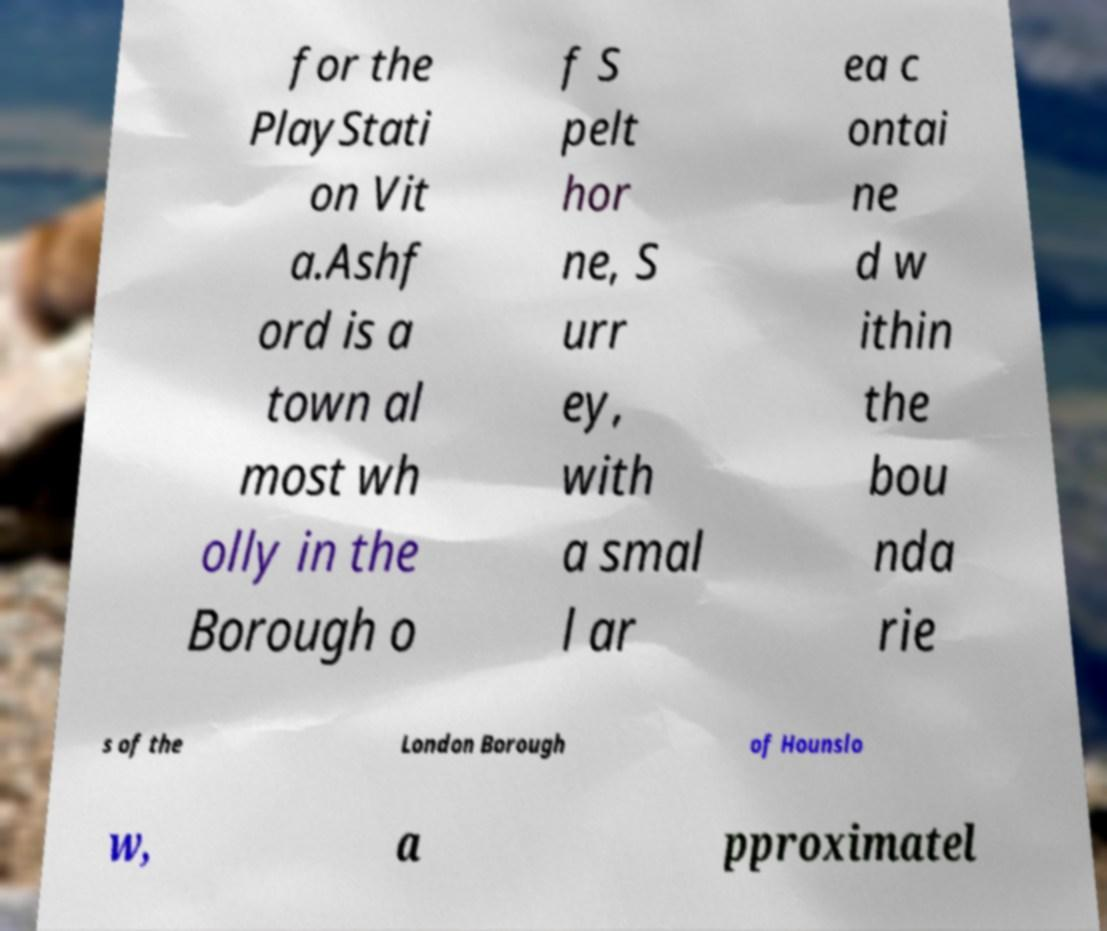For documentation purposes, I need the text within this image transcribed. Could you provide that? for the PlayStati on Vit a.Ashf ord is a town al most wh olly in the Borough o f S pelt hor ne, S urr ey, with a smal l ar ea c ontai ne d w ithin the bou nda rie s of the London Borough of Hounslo w, a pproximatel 